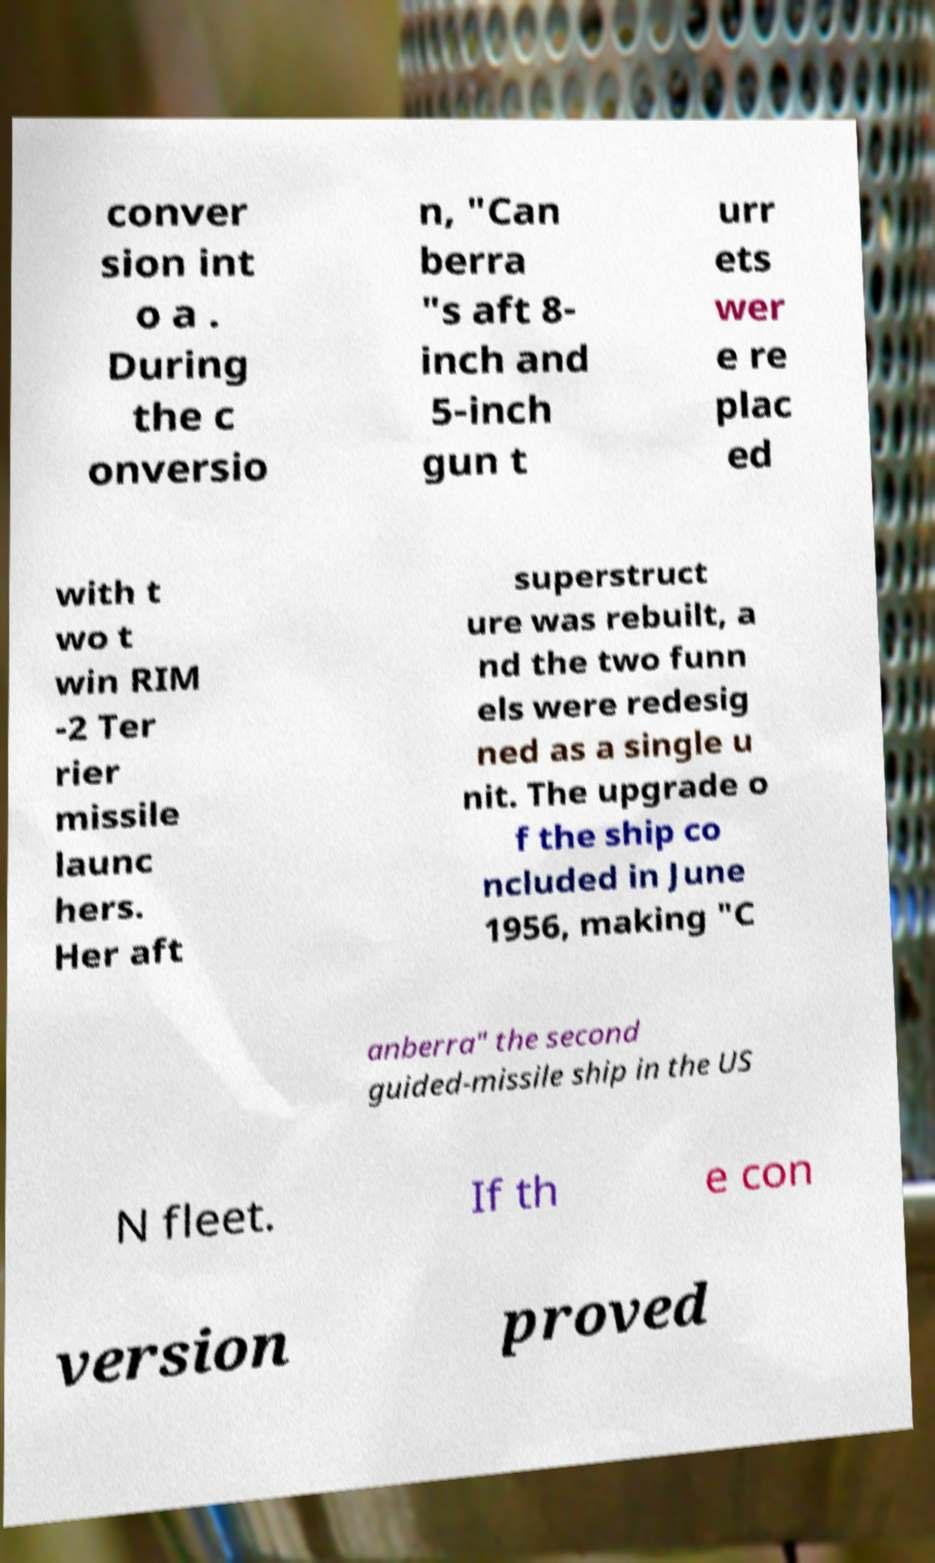Can you read and provide the text displayed in the image?This photo seems to have some interesting text. Can you extract and type it out for me? conver sion int o a . During the c onversio n, "Can berra "s aft 8- inch and 5-inch gun t urr ets wer e re plac ed with t wo t win RIM -2 Ter rier missile launc hers. Her aft superstruct ure was rebuilt, a nd the two funn els were redesig ned as a single u nit. The upgrade o f the ship co ncluded in June 1956, making "C anberra" the second guided-missile ship in the US N fleet. If th e con version proved 